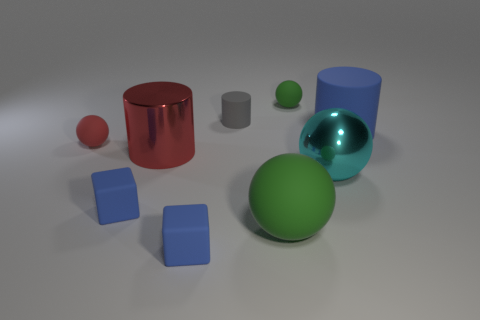Subtract all shiny cylinders. How many cylinders are left? 2 Subtract all cubes. How many objects are left? 7 Subtract 3 spheres. How many spheres are left? 1 Subtract all brown cylinders. How many green blocks are left? 0 Subtract all gray metal cylinders. Subtract all tiny green spheres. How many objects are left? 8 Add 3 tiny rubber cylinders. How many tiny rubber cylinders are left? 4 Add 9 large cyan objects. How many large cyan objects exist? 10 Subtract all green balls. How many balls are left? 2 Subtract 1 cyan balls. How many objects are left? 8 Subtract all purple cylinders. Subtract all red cubes. How many cylinders are left? 3 